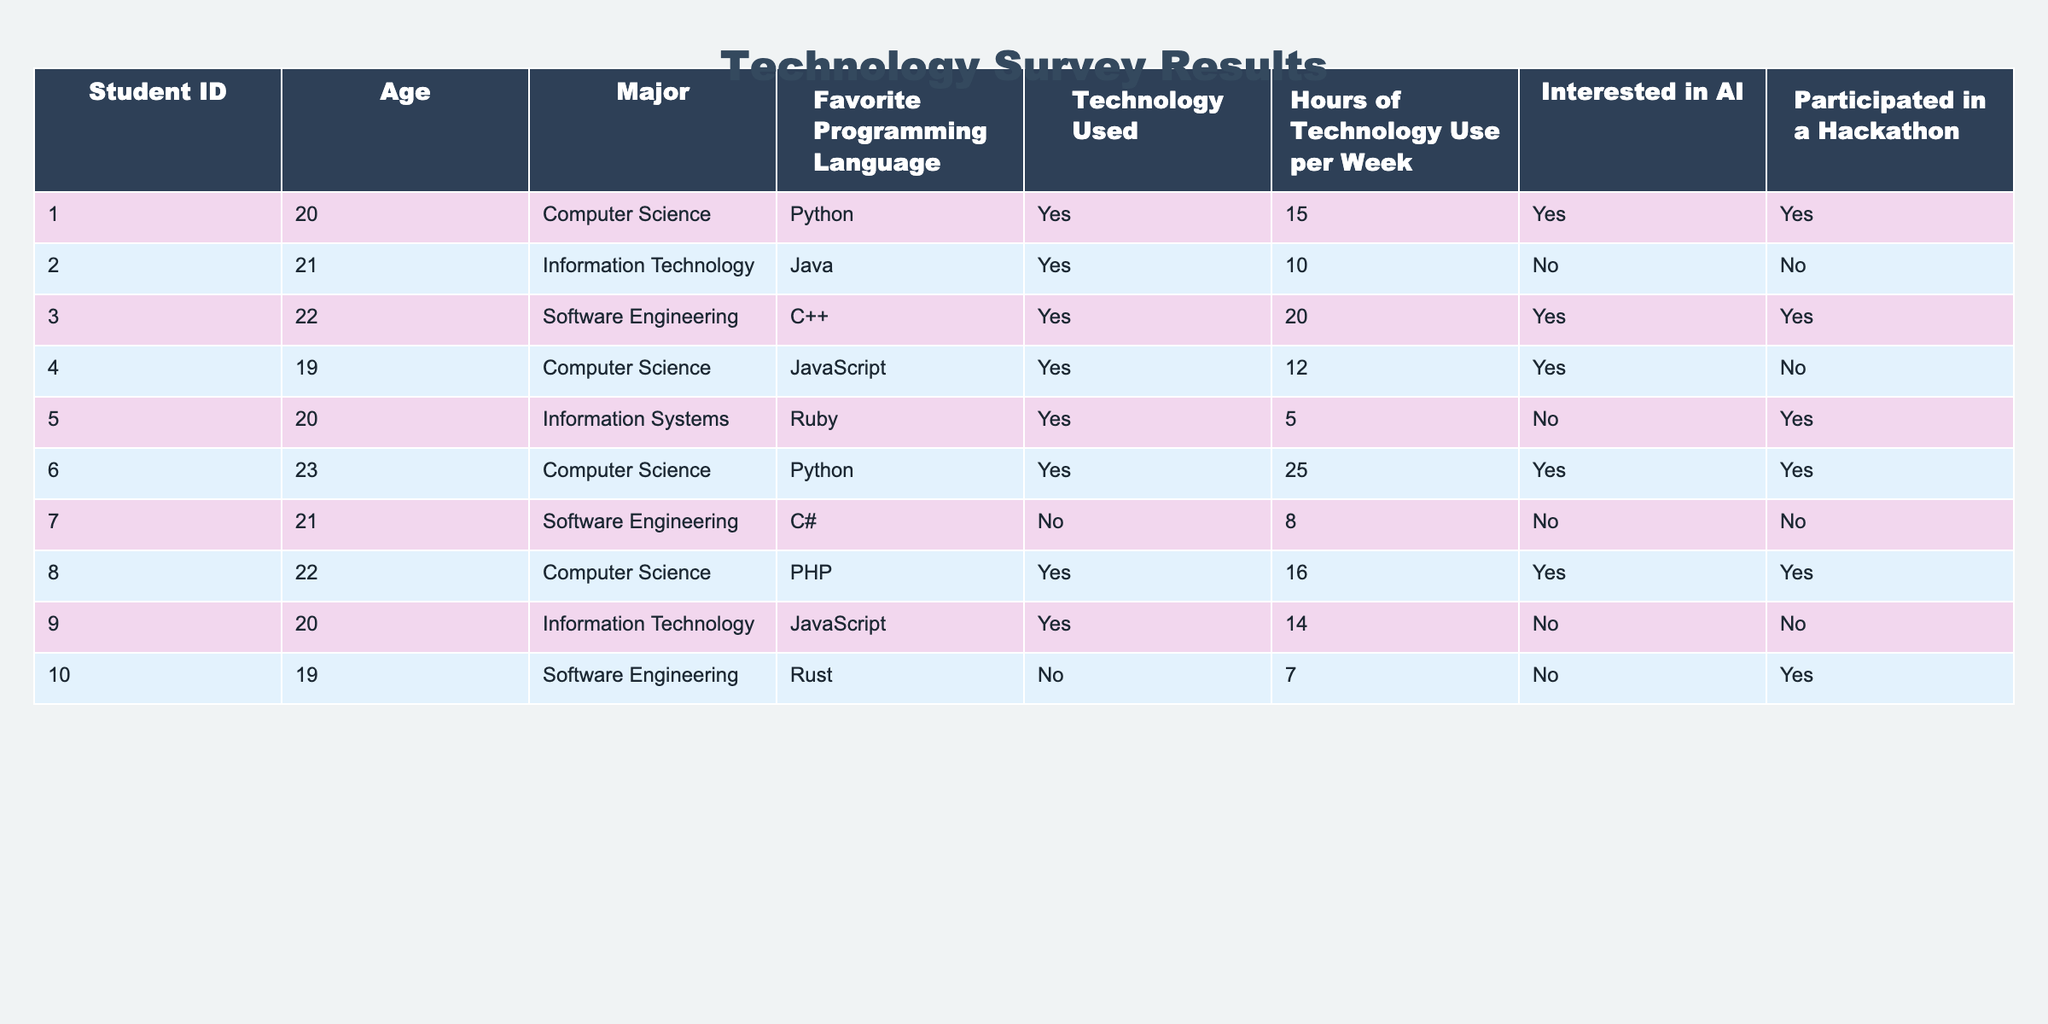What is the most common favorite programming language among the students? By scanning the "Favorite Programming Language" column, the languages mentioned are Python, Java, C++, JavaScript, Ruby, and Rust. Observing the frequencies, Python appears 3 times, Java and JavaScript each 2 times, C++ and C# once, and Ruby and Rust only once. Therefore, Python is the most common language.
Answer: Python How many students reported using technology for more than 15 hours per week? The "Hours of Technology Use per Week" column shows values of 15, 10, 20, 12, 5, 25, 8, 16, 14, and 7. Filtering for those using technology over 15 hours, we identify the students with values 20, 25, and 16, which gives us a total of 3 students.
Answer: 3 Is there any student who is interested in AI but has not participated in a hackathon? From the table, we can look at the "Interested in AI" column, which has 'Yes' for students 001, 003, 006, 004, and 008. Then, we check the "Participated in a Hackathon" column for those students. Students 001, 003, and 006 participated in a hackathon, while 004 and 008 did not. Hence, there are two students (004 and 008) who are interested in AI but did not participate.
Answer: Yes Calculate the average hours of technology use per week among students in Computer Science majors. The students in the Computer Science major according to the table are 001, 004, 006, and 008. Their corresponding hours of technology use per week are 15, 12, 25, and 16. To find the average, we sum those hours (15 + 12 + 25 + 16) = 68. Dividing by the number of students (4), the average is 68 / 4 = 17.
Answer: 17 Are there any students who use C# and are interested in AI? Looking at the table, student 007 is using C# and shows 'No' in the "Interested in AI" column. No other students are listed with C# as their favorite language, so there are no students using C# who are interested in AI.
Answer: No How many total students are interested in AI? By checking the "Interested in AI" column, we note the 'Yes' responses for students 001, 003, 006, 004, and 008. Counting these yields a total of 5 students who are interested in AI.
Answer: 5 Which major has the highest number of students participating in hackathons? Review the "Participated in a Hackathon" column and count the participation by major. The counts are: Computer Science (students 001, 003, 006, 008) = 4, Information Technology (student 002) = 0, Software Engineering (students 004, 010) = 1, Information Systems (student 005) = 1. Hence, Computer Science has the highest participation with 4 students participating in hackathons.
Answer: Computer Science Is there any student who uses PHP and has participated in a hackathon? From the table, we see Student 008 uses PHP and also has a 'Yes' in the "Participated in a Hackathon" column. So, there exists at least one student who fits this condition.
Answer: Yes 